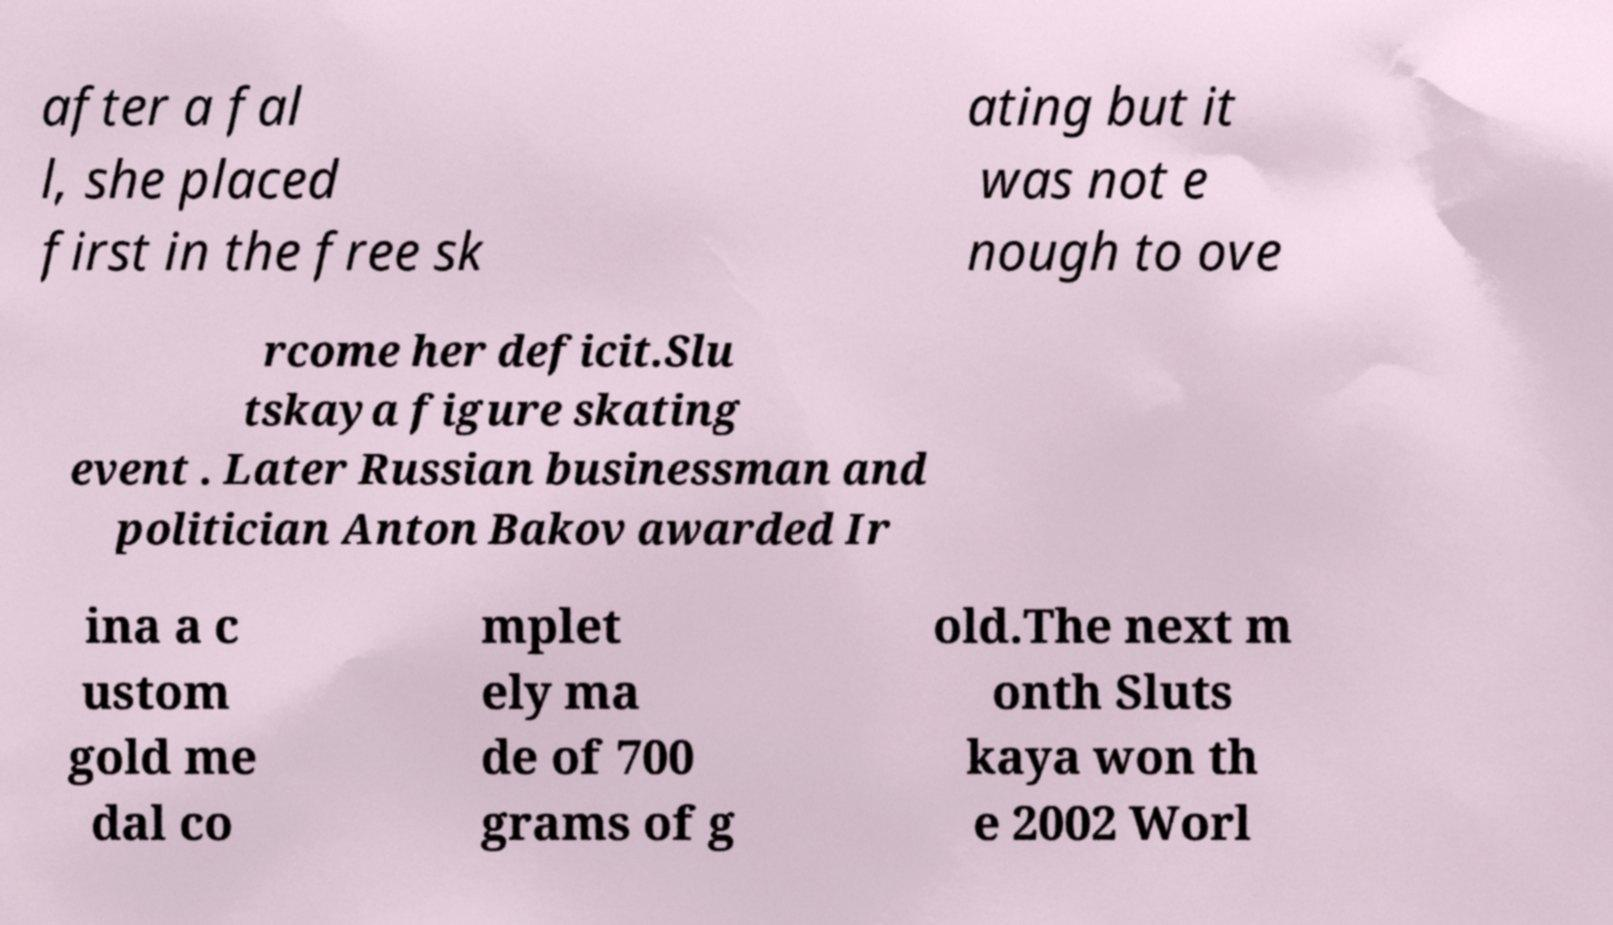Can you read and provide the text displayed in the image?This photo seems to have some interesting text. Can you extract and type it out for me? after a fal l, she placed first in the free sk ating but it was not e nough to ove rcome her deficit.Slu tskaya figure skating event . Later Russian businessman and politician Anton Bakov awarded Ir ina a c ustom gold me dal co mplet ely ma de of 700 grams of g old.The next m onth Sluts kaya won th e 2002 Worl 